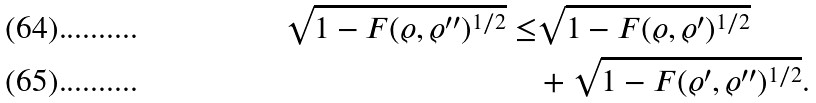<formula> <loc_0><loc_0><loc_500><loc_500>\sqrt { 1 - F ( \varrho , \varrho ^ { \prime \prime } ) ^ { 1 / 2 } } \leq & \sqrt { 1 - F ( \varrho , \varrho ^ { \prime } ) ^ { 1 / 2 } } \\ & + \sqrt { 1 - F ( \varrho ^ { \prime } , \varrho ^ { \prime \prime } ) ^ { 1 / 2 } } .</formula> 